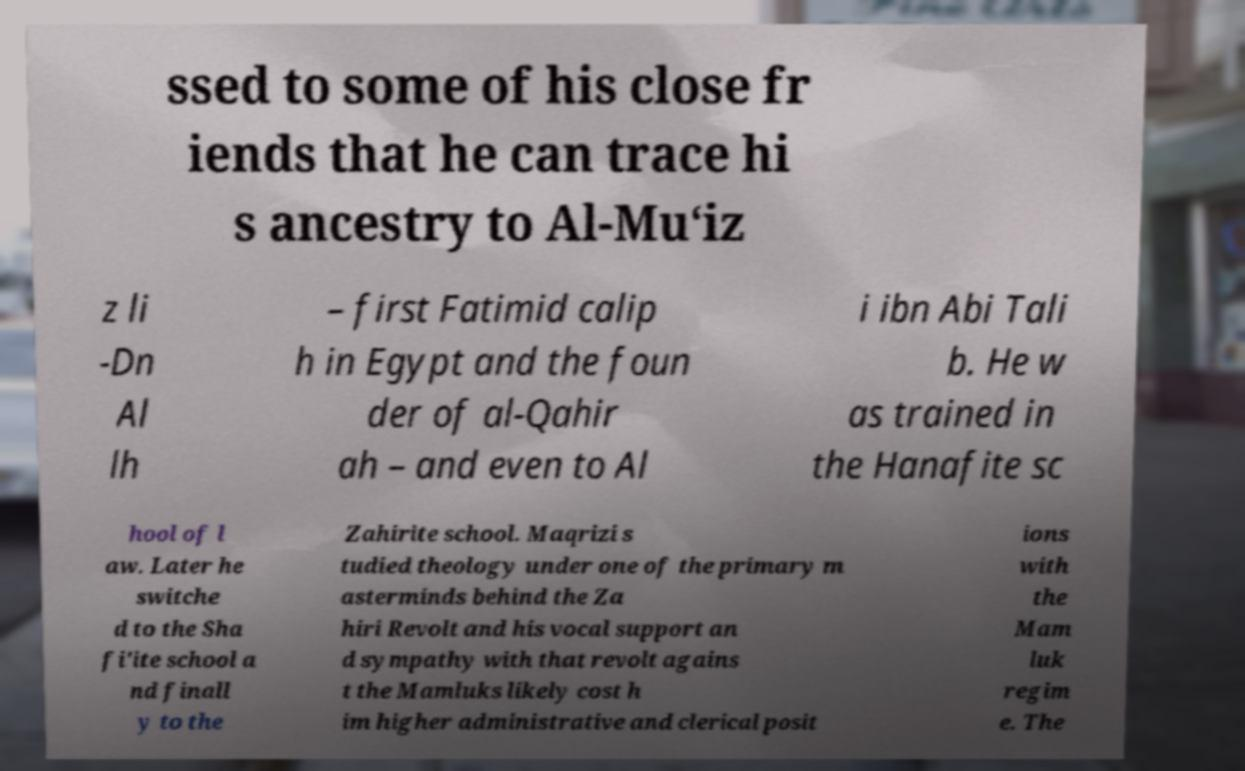Please identify and transcribe the text found in this image. ssed to some of his close fr iends that he can trace hi s ancestry to Al-Mu‘iz z li -Dn Al lh – first Fatimid calip h in Egypt and the foun der of al-Qahir ah – and even to Al i ibn Abi Tali b. He w as trained in the Hanafite sc hool of l aw. Later he switche d to the Sha fi'ite school a nd finall y to the Zahirite school. Maqrizi s tudied theology under one of the primary m asterminds behind the Za hiri Revolt and his vocal support an d sympathy with that revolt agains t the Mamluks likely cost h im higher administrative and clerical posit ions with the Mam luk regim e. The 